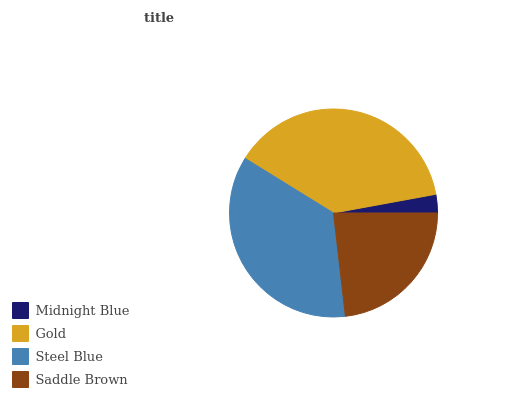Is Midnight Blue the minimum?
Answer yes or no. Yes. Is Gold the maximum?
Answer yes or no. Yes. Is Steel Blue the minimum?
Answer yes or no. No. Is Steel Blue the maximum?
Answer yes or no. No. Is Gold greater than Steel Blue?
Answer yes or no. Yes. Is Steel Blue less than Gold?
Answer yes or no. Yes. Is Steel Blue greater than Gold?
Answer yes or no. No. Is Gold less than Steel Blue?
Answer yes or no. No. Is Steel Blue the high median?
Answer yes or no. Yes. Is Saddle Brown the low median?
Answer yes or no. Yes. Is Gold the high median?
Answer yes or no. No. Is Midnight Blue the low median?
Answer yes or no. No. 